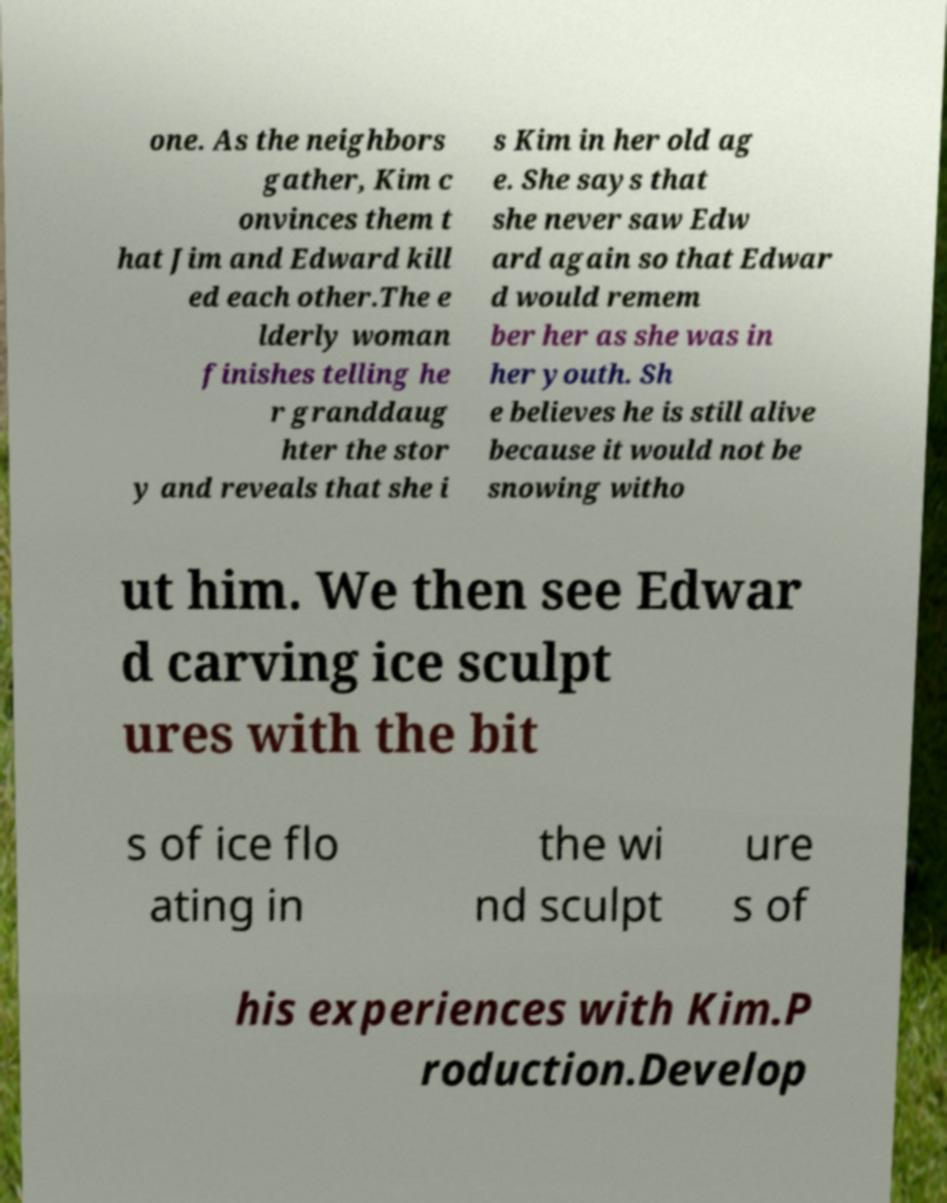For documentation purposes, I need the text within this image transcribed. Could you provide that? one. As the neighbors gather, Kim c onvinces them t hat Jim and Edward kill ed each other.The e lderly woman finishes telling he r granddaug hter the stor y and reveals that she i s Kim in her old ag e. She says that she never saw Edw ard again so that Edwar d would remem ber her as she was in her youth. Sh e believes he is still alive because it would not be snowing witho ut him. We then see Edwar d carving ice sculpt ures with the bit s of ice flo ating in the wi nd sculpt ure s of his experiences with Kim.P roduction.Develop 